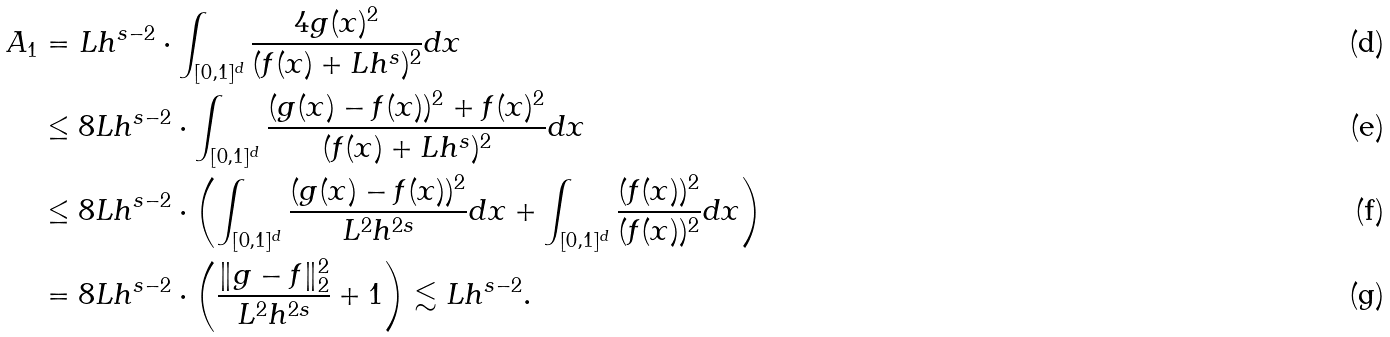<formula> <loc_0><loc_0><loc_500><loc_500>A _ { 1 } & = L h ^ { s - 2 } \cdot \int _ { [ 0 , 1 ] ^ { d } } \frac { 4 g ( x ) ^ { 2 } } { ( f ( x ) + L h ^ { s } ) ^ { 2 } } d x \\ & \leq 8 L h ^ { s - 2 } \cdot \int _ { [ 0 , 1 ] ^ { d } } \frac { ( g ( x ) - f ( x ) ) ^ { 2 } + f ( x ) ^ { 2 } } { ( f ( x ) + L h ^ { s } ) ^ { 2 } } d x \\ & \leq 8 L h ^ { s - 2 } \cdot \left ( \int _ { [ 0 , 1 ] ^ { d } } \frac { ( g ( x ) - f ( x ) ) ^ { 2 } } { L ^ { 2 } h ^ { 2 s } } d x + \int _ { [ 0 , 1 ] ^ { d } } \frac { ( f ( x ) ) ^ { 2 } } { ( f ( x ) ) ^ { 2 } } d x \right ) \\ & = 8 L h ^ { s - 2 } \cdot \left ( \frac { \| g - f \| _ { 2 } ^ { 2 } } { L ^ { 2 } h ^ { 2 s } } + 1 \right ) \lesssim L h ^ { s - 2 } .</formula> 